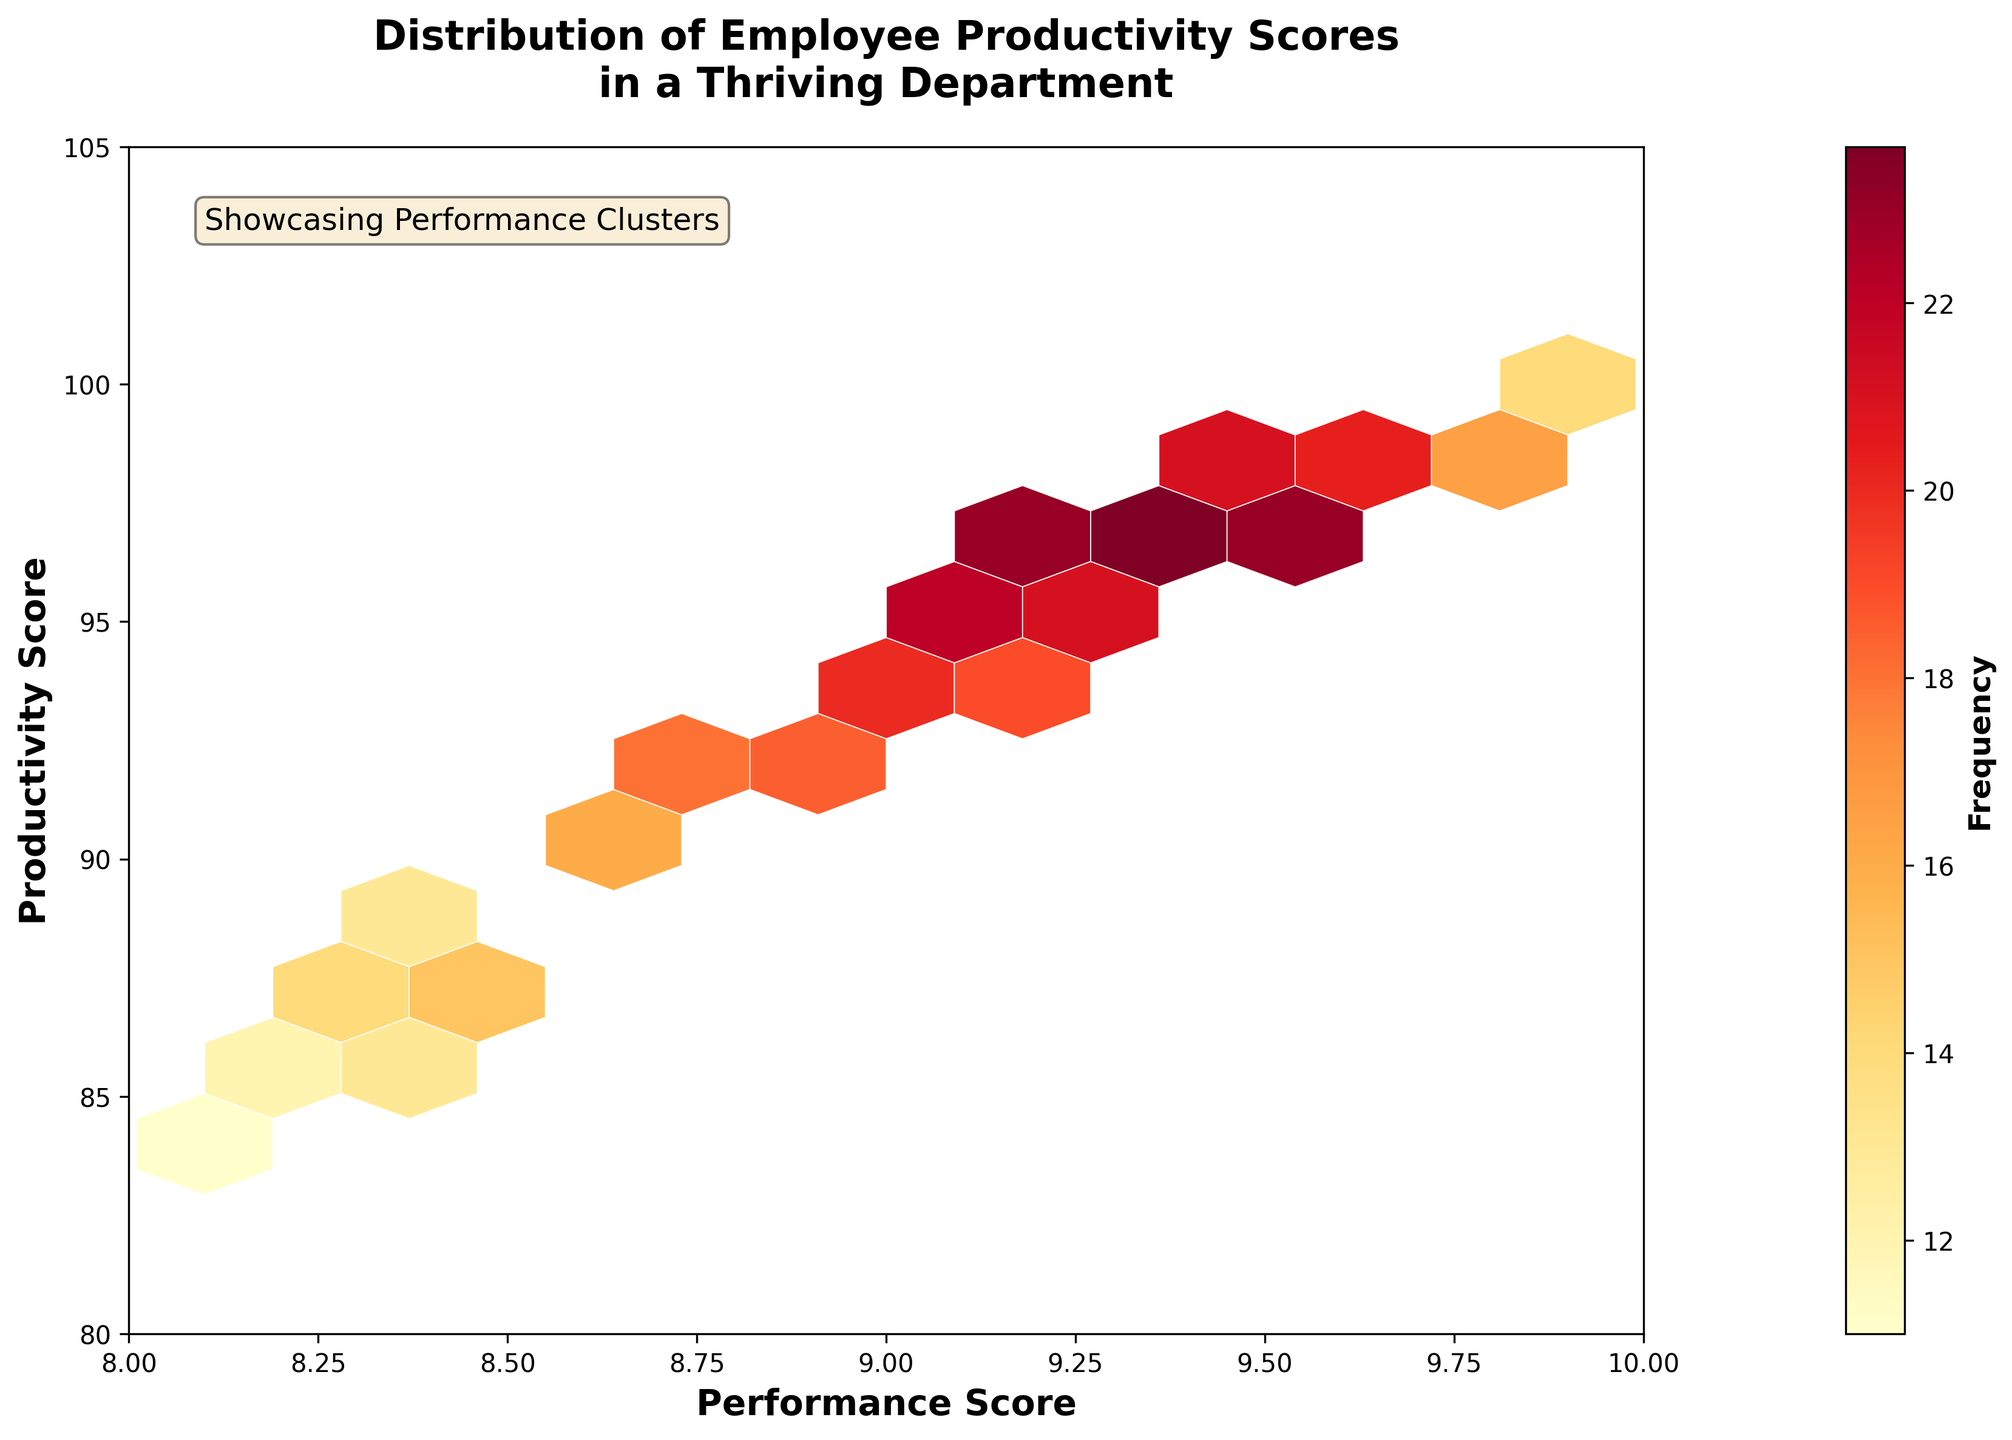what is the title of the plot? The title of the plot is presented at the top in bold. It reads "Distribution of Employee Productivity Scores in a Thriving Department."
Answer: Distribution of Employee Productivity Scores in a Thriving Department what do the colors in the hexbin plot represent? The colors in the hexbin plot represent the frequency of the data points in each hexagonal bin. The color bar on the right side of the plot shows that deeper shades represent higher frequencies.
Answer: frequency of the data points what is the range of performance scores displayed on the x-axis? The x-axis is labeled as "Performance Score" and ranges from 8 to 10, as indicated by the axis limits.
Answer: 8 to 10 how many data points fall within the highest frequency range? To find how many data points fall within the highest frequency range, look for the deepest shade of color as indicated in the color bar. The highest frequency corresponding to these areas is 25.
Answer: 25 what is the relationship between productivity scores and performance scores? The trend in the hexbin plot indicates that as performance scores increase, productivity scores also increase, suggesting a positive relationship between the two variables.
Answer: positive relationship where are the majority of productivity scores clustered? The majority of productivity scores are clustered in the upper right of the plot, where both performance scores and productivity scores are high, as indicated by the denser, darker-colored hexagons.
Answer: upper right of the plot what is the average productivity score for performance scores of 9.2? To calculate the average productivity score for performance scores of 9.2, look at the bins around x = 9.2. The corresponding y-values range from 95 to 96, averaging to (95+96)/2 = 95.5.
Answer: 95.5 how does the frequency of data points change from a performance score of 8.5 to 9.5? The hexbin plot shows that frequency generally increases as performance scores move from 8.5 to 9.5. The color intensity becomes darker, implying more data points clustered in this range.
Answer: increases which performance score has the least productivity variance? To determine this, observe the horizontal spread of productivity scores for each performance score. The performance score of 9.7 appears to have the least variance, with productivity scores tightly clustered around 98.
Answer: 9.7 is there any productivity score above 100? According to the hexbin plot, the y-axis ranges from 80 to 105, but there are no hexagons indicating data points with productivity scores above 100.
Answer: no 